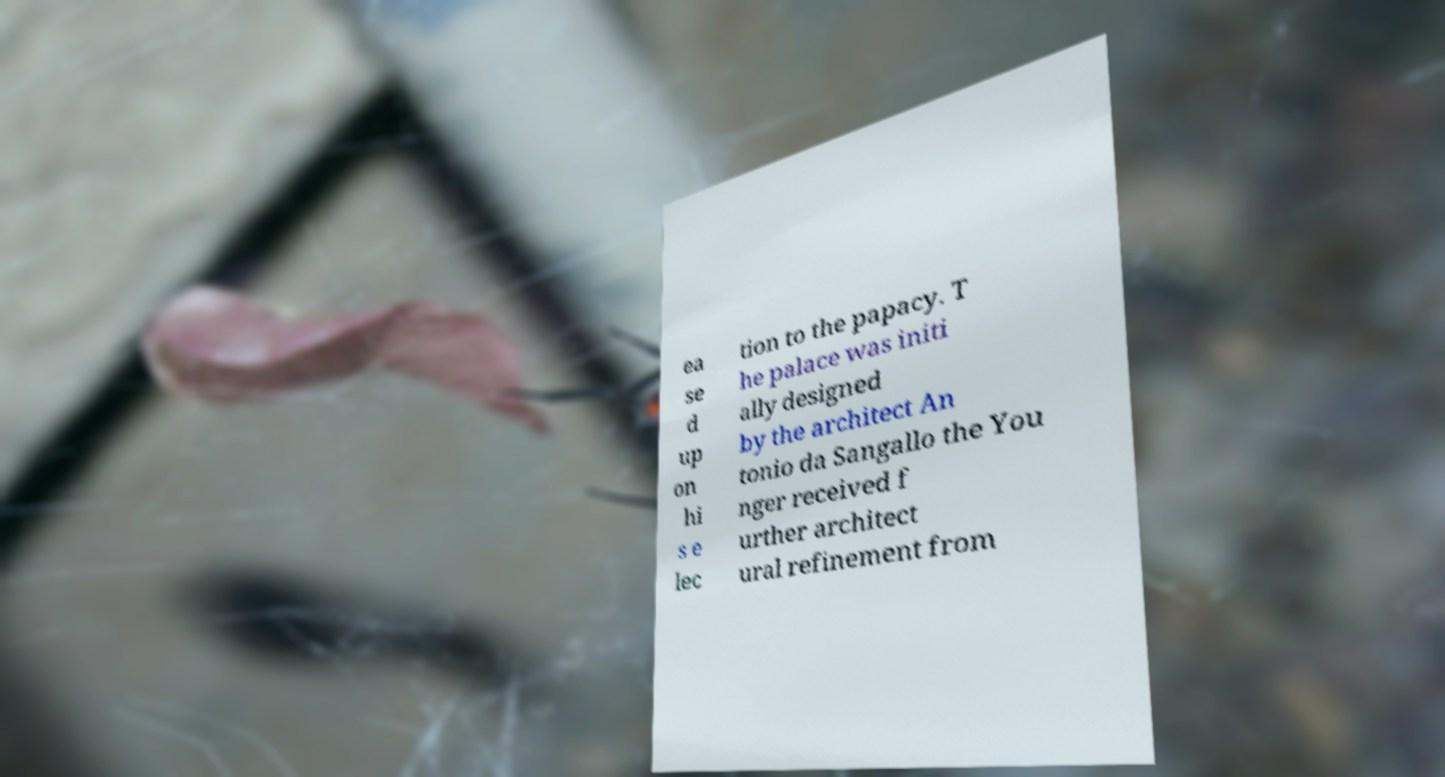Could you assist in decoding the text presented in this image and type it out clearly? ea se d up on hi s e lec tion to the papacy. T he palace was initi ally designed by the architect An tonio da Sangallo the You nger received f urther architect ural refinement from 